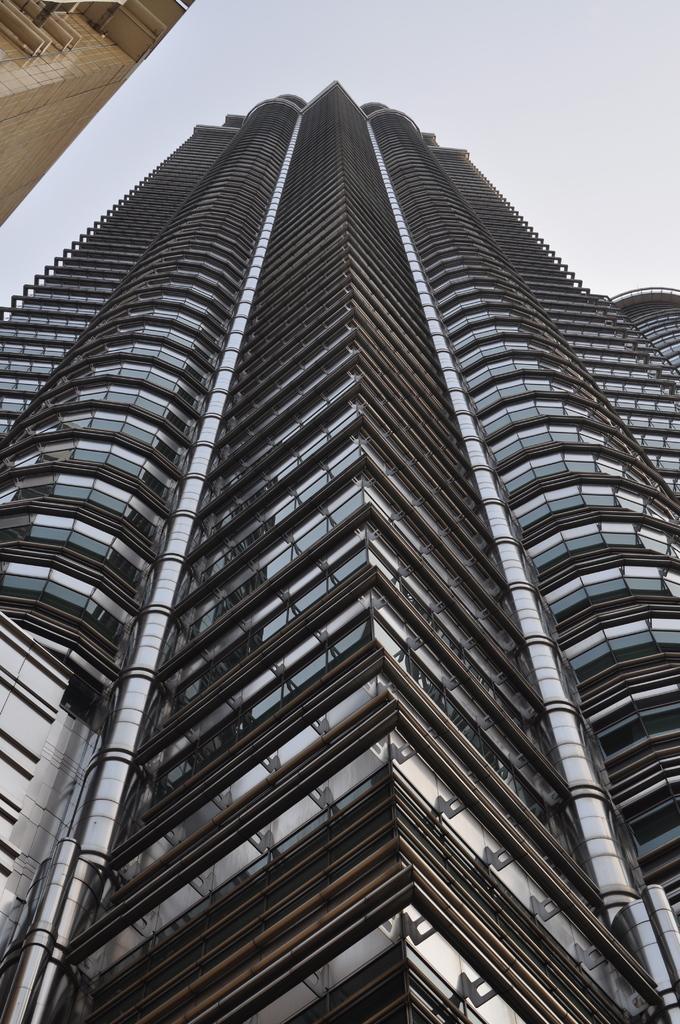Describe this image in one or two sentences. As we can see in the image there are buildings and at the top there is sky. 